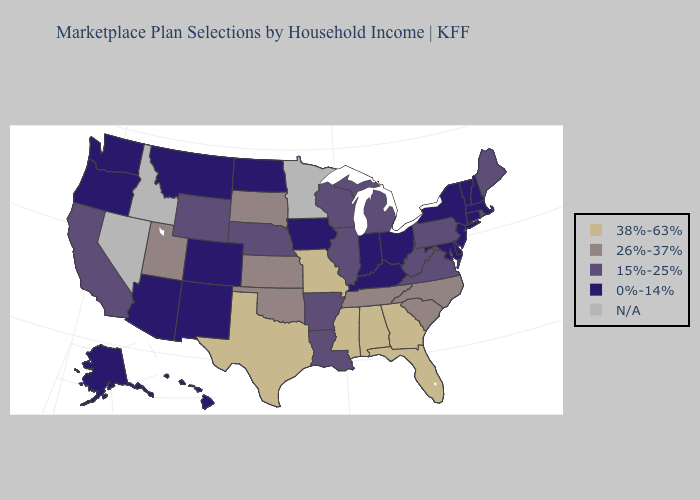What is the value of New Hampshire?
Write a very short answer. 0%-14%. Among the states that border Arizona , which have the lowest value?
Be succinct. Colorado, New Mexico. Name the states that have a value in the range N/A?
Give a very brief answer. Idaho, Minnesota, Nevada. What is the highest value in states that border Idaho?
Concise answer only. 26%-37%. What is the lowest value in states that border New Hampshire?
Concise answer only. 0%-14%. What is the value of South Carolina?
Be succinct. 26%-37%. Name the states that have a value in the range 26%-37%?
Concise answer only. Kansas, North Carolina, Oklahoma, South Carolina, South Dakota, Tennessee, Utah. What is the value of Georgia?
Quick response, please. 38%-63%. What is the lowest value in the West?
Answer briefly. 0%-14%. Name the states that have a value in the range 15%-25%?
Give a very brief answer. Arkansas, California, Illinois, Louisiana, Maine, Michigan, Nebraska, Pennsylvania, Rhode Island, Virginia, West Virginia, Wisconsin, Wyoming. How many symbols are there in the legend?
Short answer required. 5. How many symbols are there in the legend?
Write a very short answer. 5. Which states have the lowest value in the MidWest?
Write a very short answer. Indiana, Iowa, North Dakota, Ohio. What is the value of Tennessee?
Short answer required. 26%-37%. Which states hav the highest value in the MidWest?
Be succinct. Missouri. 